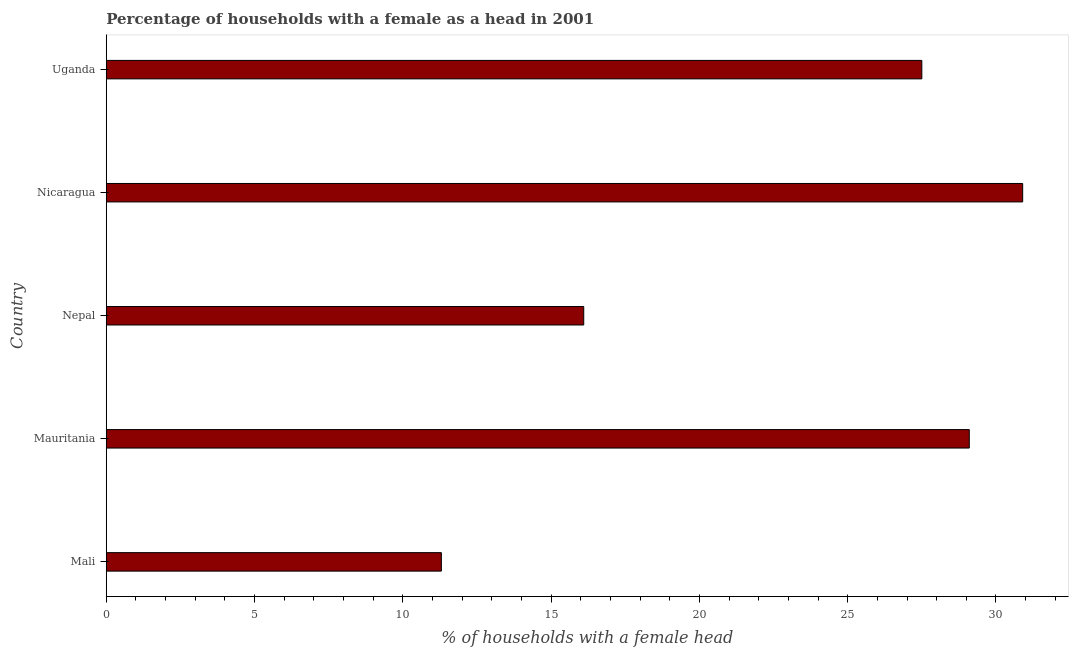What is the title of the graph?
Keep it short and to the point. Percentage of households with a female as a head in 2001. What is the label or title of the X-axis?
Offer a terse response. % of households with a female head. What is the number of female supervised households in Nicaragua?
Make the answer very short. 30.9. Across all countries, what is the maximum number of female supervised households?
Make the answer very short. 30.9. In which country was the number of female supervised households maximum?
Your answer should be very brief. Nicaragua. In which country was the number of female supervised households minimum?
Keep it short and to the point. Mali. What is the sum of the number of female supervised households?
Give a very brief answer. 114.9. What is the difference between the number of female supervised households in Mali and Nicaragua?
Ensure brevity in your answer.  -19.6. What is the average number of female supervised households per country?
Your answer should be compact. 22.98. What is the median number of female supervised households?
Offer a very short reply. 27.5. What is the ratio of the number of female supervised households in Nicaragua to that in Uganda?
Offer a very short reply. 1.12. Is the number of female supervised households in Mali less than that in Nepal?
Offer a very short reply. Yes. What is the difference between the highest and the second highest number of female supervised households?
Your answer should be very brief. 1.8. Is the sum of the number of female supervised households in Nepal and Uganda greater than the maximum number of female supervised households across all countries?
Your response must be concise. Yes. What is the difference between the highest and the lowest number of female supervised households?
Your response must be concise. 19.6. How many countries are there in the graph?
Offer a terse response. 5. What is the % of households with a female head of Mali?
Keep it short and to the point. 11.3. What is the % of households with a female head in Mauritania?
Your answer should be compact. 29.1. What is the % of households with a female head of Nicaragua?
Your response must be concise. 30.9. What is the % of households with a female head in Uganda?
Provide a succinct answer. 27.5. What is the difference between the % of households with a female head in Mali and Mauritania?
Your answer should be compact. -17.8. What is the difference between the % of households with a female head in Mali and Nicaragua?
Ensure brevity in your answer.  -19.6. What is the difference between the % of households with a female head in Mali and Uganda?
Keep it short and to the point. -16.2. What is the difference between the % of households with a female head in Mauritania and Nepal?
Make the answer very short. 13. What is the difference between the % of households with a female head in Mauritania and Nicaragua?
Your response must be concise. -1.8. What is the difference between the % of households with a female head in Nepal and Nicaragua?
Keep it short and to the point. -14.8. What is the difference between the % of households with a female head in Nepal and Uganda?
Offer a terse response. -11.4. What is the difference between the % of households with a female head in Nicaragua and Uganda?
Provide a succinct answer. 3.4. What is the ratio of the % of households with a female head in Mali to that in Mauritania?
Ensure brevity in your answer.  0.39. What is the ratio of the % of households with a female head in Mali to that in Nepal?
Your response must be concise. 0.7. What is the ratio of the % of households with a female head in Mali to that in Nicaragua?
Your response must be concise. 0.37. What is the ratio of the % of households with a female head in Mali to that in Uganda?
Provide a short and direct response. 0.41. What is the ratio of the % of households with a female head in Mauritania to that in Nepal?
Give a very brief answer. 1.81. What is the ratio of the % of households with a female head in Mauritania to that in Nicaragua?
Offer a very short reply. 0.94. What is the ratio of the % of households with a female head in Mauritania to that in Uganda?
Offer a terse response. 1.06. What is the ratio of the % of households with a female head in Nepal to that in Nicaragua?
Your answer should be compact. 0.52. What is the ratio of the % of households with a female head in Nepal to that in Uganda?
Provide a short and direct response. 0.58. What is the ratio of the % of households with a female head in Nicaragua to that in Uganda?
Offer a terse response. 1.12. 